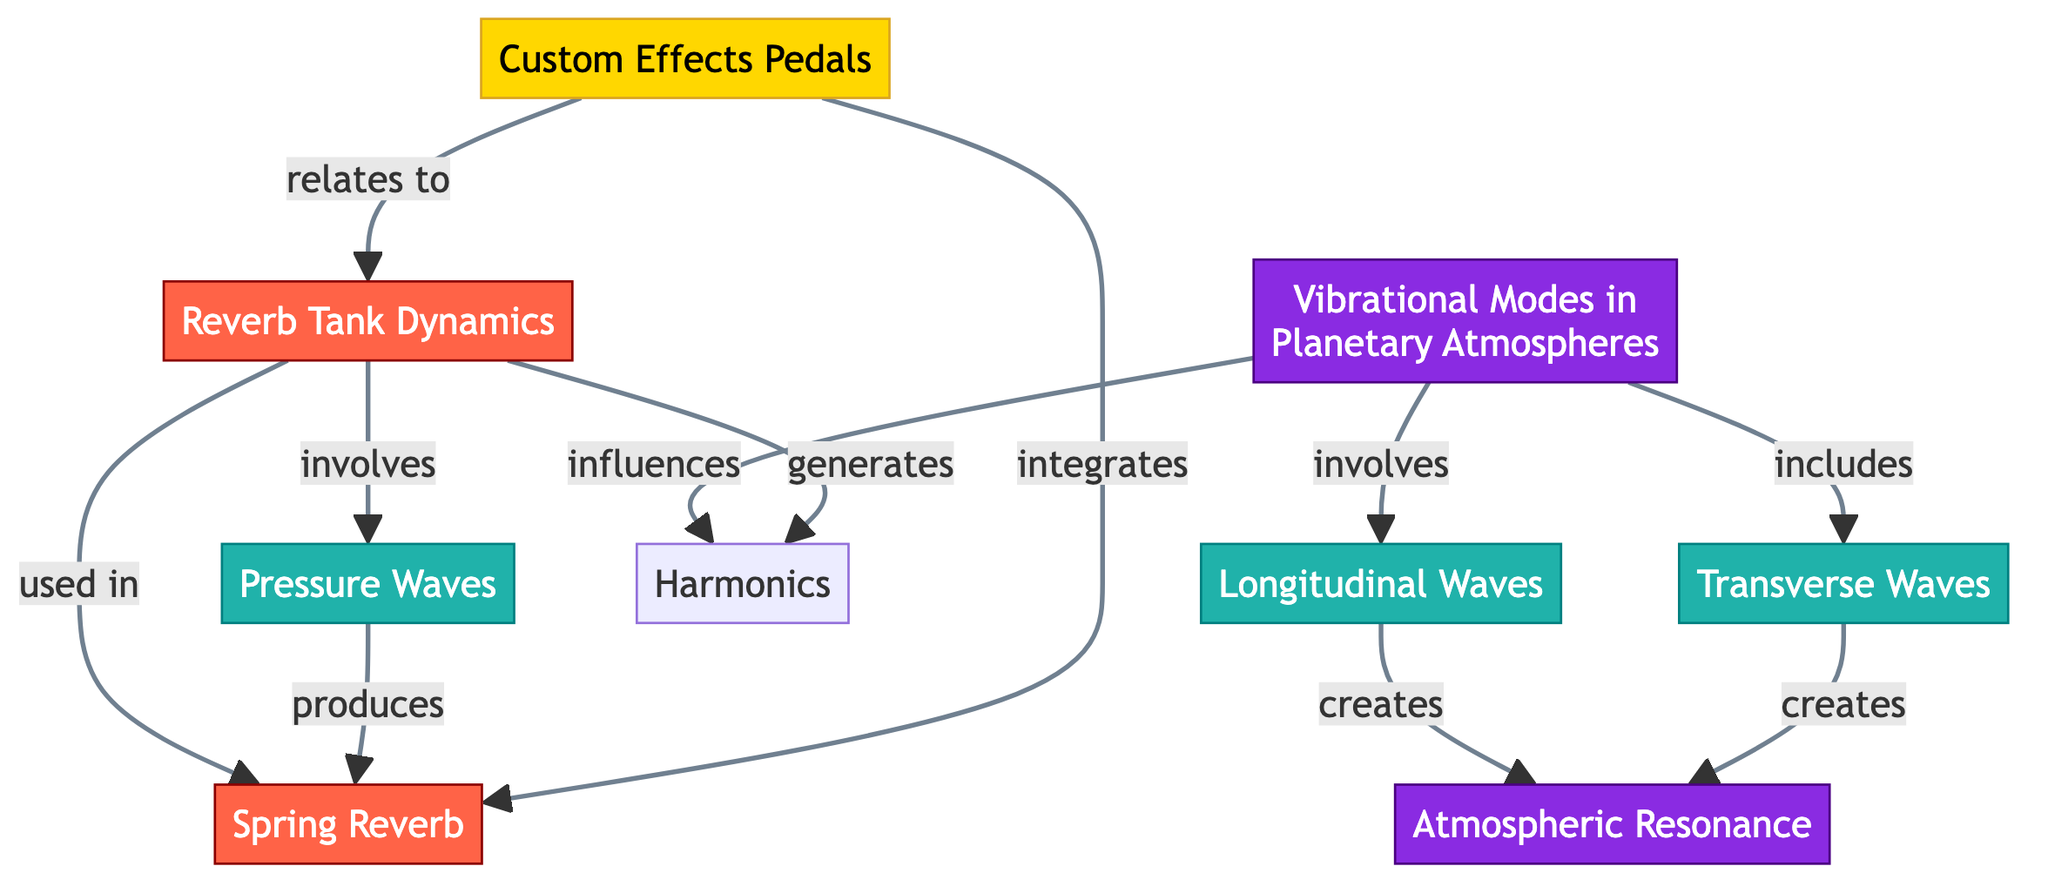What are the two main categories of waves involved in planetary atmospheres and reverb tank dynamics? The diagram shows "Longitudinal Waves" and "Transverse Waves" as key components in both planetary and reverb contexts. These are categorized under the relevant nodes in the diagram.
Answer: Longitudinal Waves, Transverse Waves How many nodes are focused on vibrational modes in planetary atmospheres? The diagram indicates there are two primary nodes dedicated to vibrational modes, one being "Vibrational Modes in Planetary Atmospheres" and the other "Atmospheric Resonance", directly related to this topic.
Answer: 2 Which component produces pressure waves in connection with reverb tank dynamics? The diagram specifically connects "Reverb Tank Dynamics" to "Pressure Waves", indicating that pressure waves are produced as part of the reverb process in the tank.
Answer: Pressure Waves In what way do vibrational modes influence harmonics? The diagram explicitly indicates that "Vibrational Modes in Planetary Atmospheres" affects "Harmonics". This shows a direct relationship where the vibrational modes lead to the creation of harmonics.
Answer: influences What relationship ties custom effects pedals to reverb tank dynamics? According to the diagram, "Custom Effects Pedals" are shown to integrate and relate to "Reverb Tank Dynamics", establishing a connection between the two components.
Answer: integrates, relates to How many relationships involve atmospheric resonance in vibrational modes? The diagram presents that atmospheric resonance is created through both longitudinal and transverse waves stemming from vibrational modes, indicating two distinct relationships.
Answer: 2 What third element is influenced by pressure waves generated in reverb dynamics? The diagram illustrates that pressure waves generate "Harmonics", thus establishing a direct linkage to this third element as a result of the pressure waves.
Answer: Harmonics 